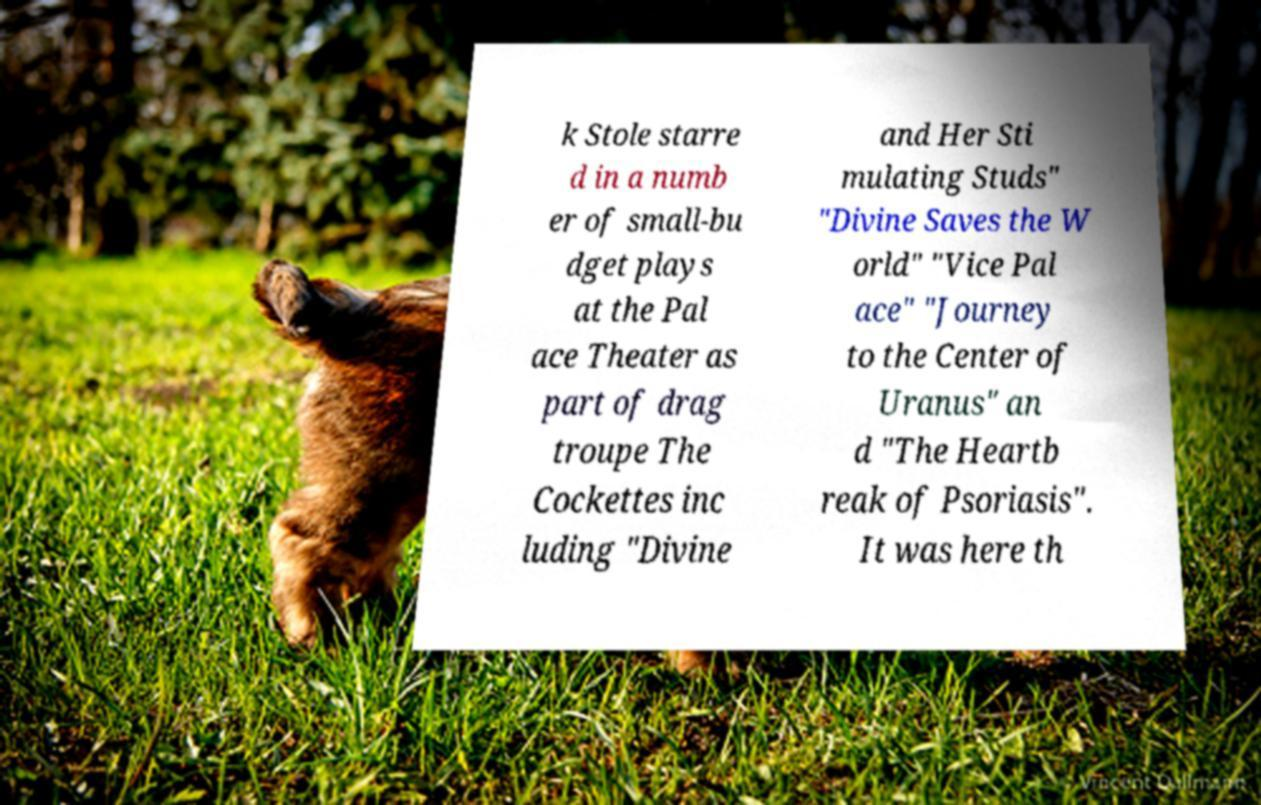There's text embedded in this image that I need extracted. Can you transcribe it verbatim? k Stole starre d in a numb er of small-bu dget plays at the Pal ace Theater as part of drag troupe The Cockettes inc luding "Divine and Her Sti mulating Studs" "Divine Saves the W orld" "Vice Pal ace" "Journey to the Center of Uranus" an d "The Heartb reak of Psoriasis". It was here th 